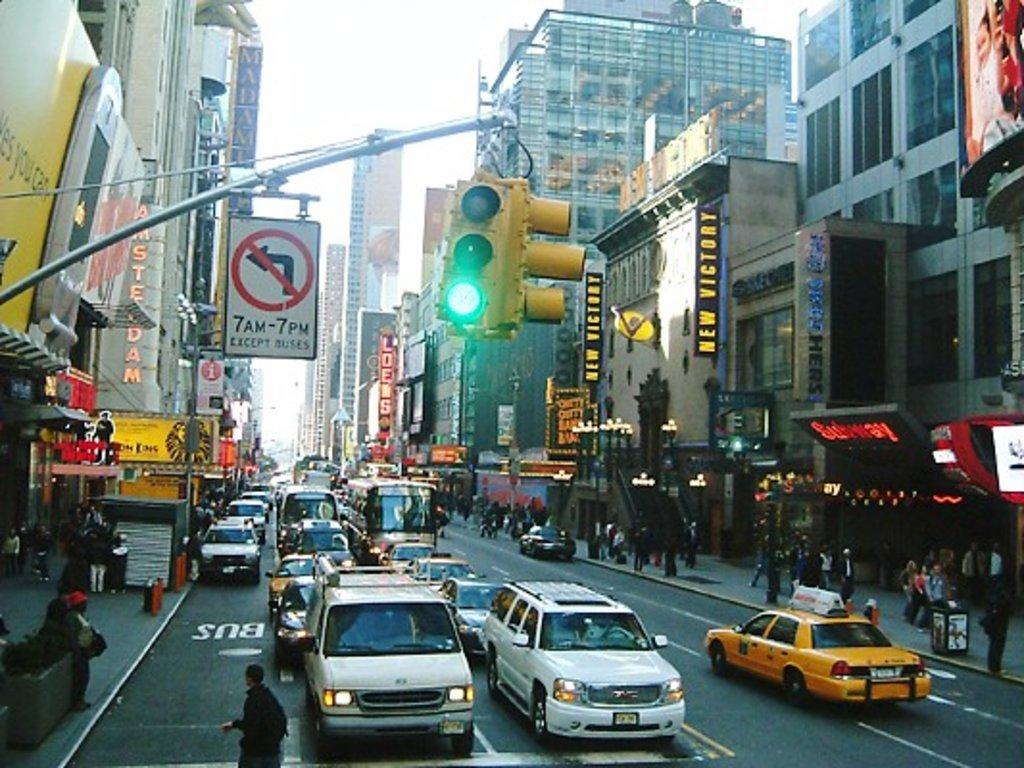What times are mentioned on the no-left-turn sign at the top?
Provide a short and direct response. 7am-7pm. What kind of vehicle is allowed to turn left between 7am and 7pm?
Offer a terse response. Buses. 